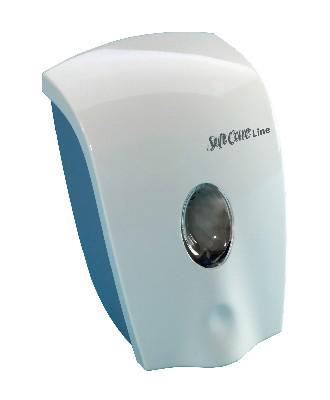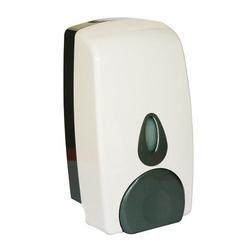The first image is the image on the left, the second image is the image on the right. Considering the images on both sides, is "One image is a standard dispenser with a pump top that does not show the level of the contents." valid? Answer yes or no. No. 